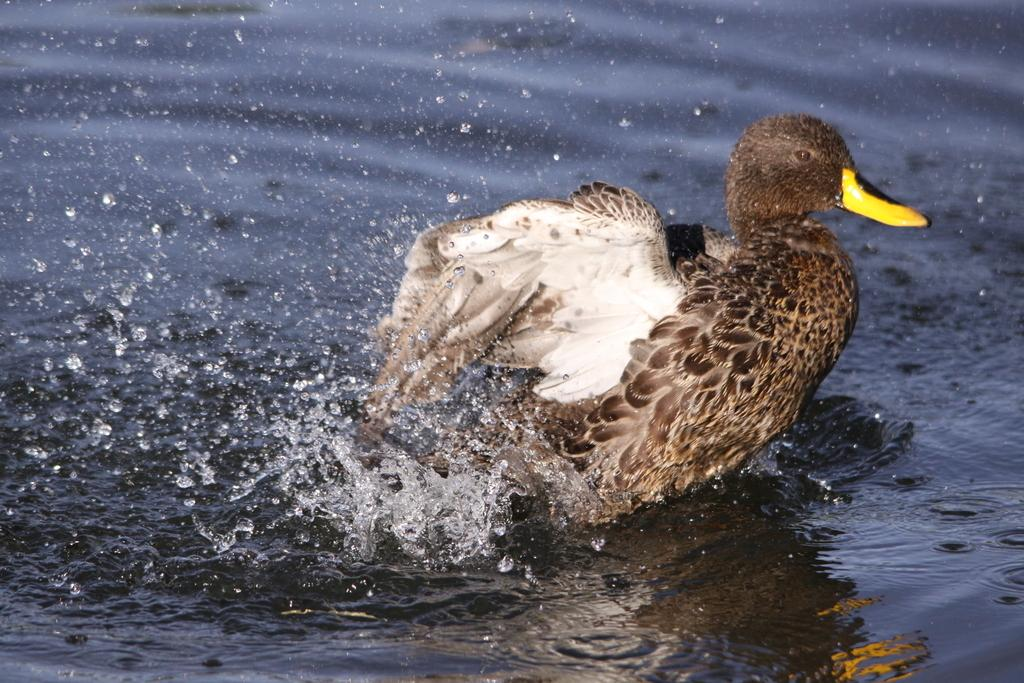What type of animal is in the image? There is a bird in the image. Where is the bird located? The bird is in water. What colors can be seen on the bird? The bird has white and brown coloring. What color is the bird's beak? The bird's beak is yellow. What rule is being enforced by the bird in the image? There is no indication in the image that the bird is enforcing any rules. 